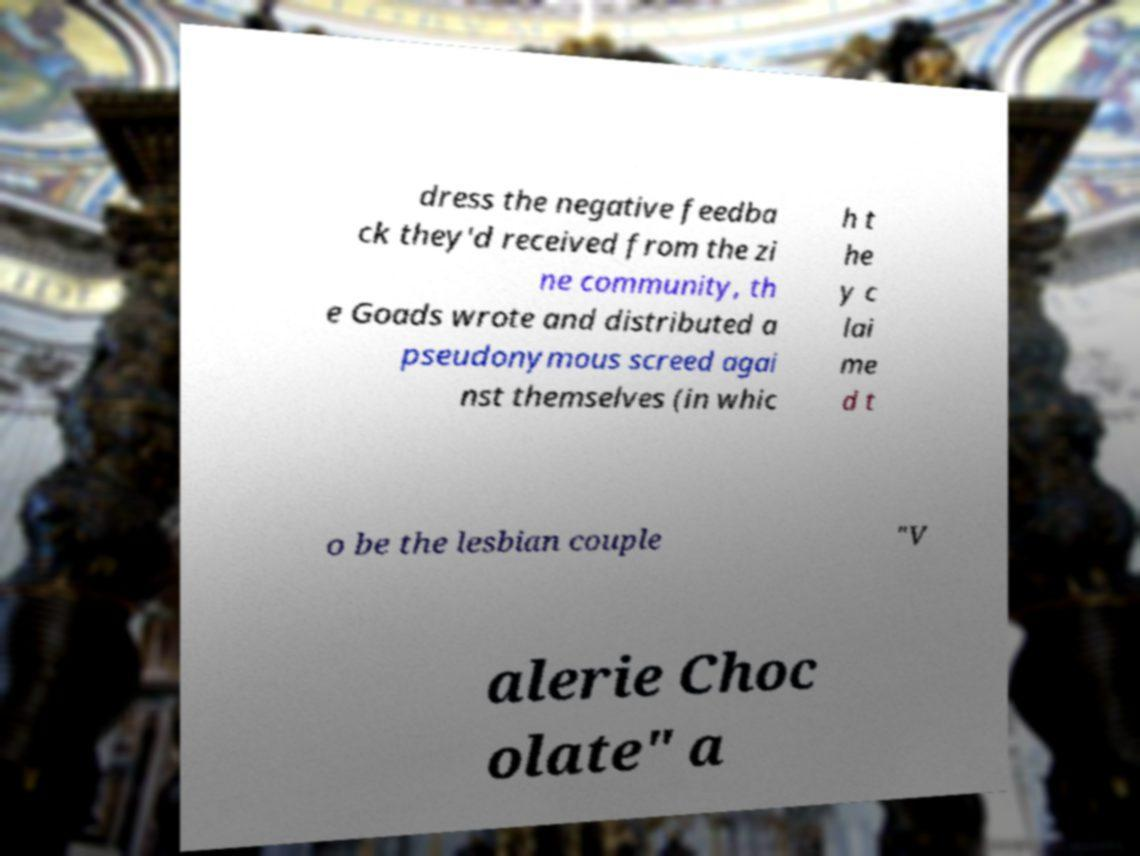Could you assist in decoding the text presented in this image and type it out clearly? dress the negative feedba ck they'd received from the zi ne community, th e Goads wrote and distributed a pseudonymous screed agai nst themselves (in whic h t he y c lai me d t o be the lesbian couple "V alerie Choc olate" a 